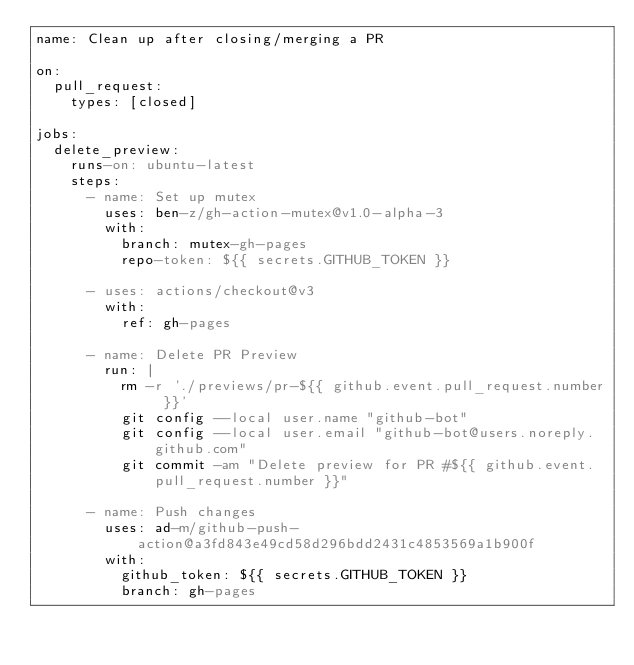<code> <loc_0><loc_0><loc_500><loc_500><_YAML_>name: Clean up after closing/merging a PR

on:
  pull_request:
    types: [closed]

jobs:
  delete_preview:
    runs-on: ubuntu-latest
    steps:
      - name: Set up mutex
        uses: ben-z/gh-action-mutex@v1.0-alpha-3
        with:
          branch: mutex-gh-pages
          repo-token: ${{ secrets.GITHUB_TOKEN }}

      - uses: actions/checkout@v3
        with:
          ref: gh-pages

      - name: Delete PR Preview
        run: |
          rm -r './previews/pr-${{ github.event.pull_request.number }}'
          git config --local user.name "github-bot"
          git config --local user.email "github-bot@users.noreply.github.com"
          git commit -am "Delete preview for PR #${{ github.event.pull_request.number }}"

      - name: Push changes
        uses: ad-m/github-push-action@a3fd843e49cd58d296bdd2431c4853569a1b900f
        with:
          github_token: ${{ secrets.GITHUB_TOKEN }}
          branch: gh-pages
</code> 